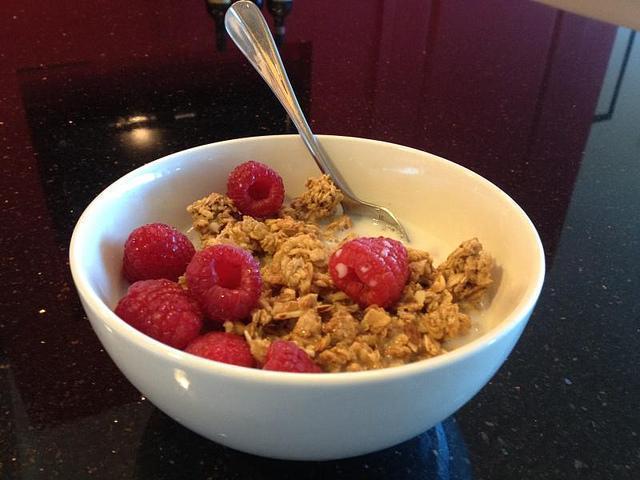Based on the reflections where is this bowl of cereal placed?
Make your selection from the four choices given to correctly answer the question.
Options: Kitchen, cafe, living room, office. Kitchen. 